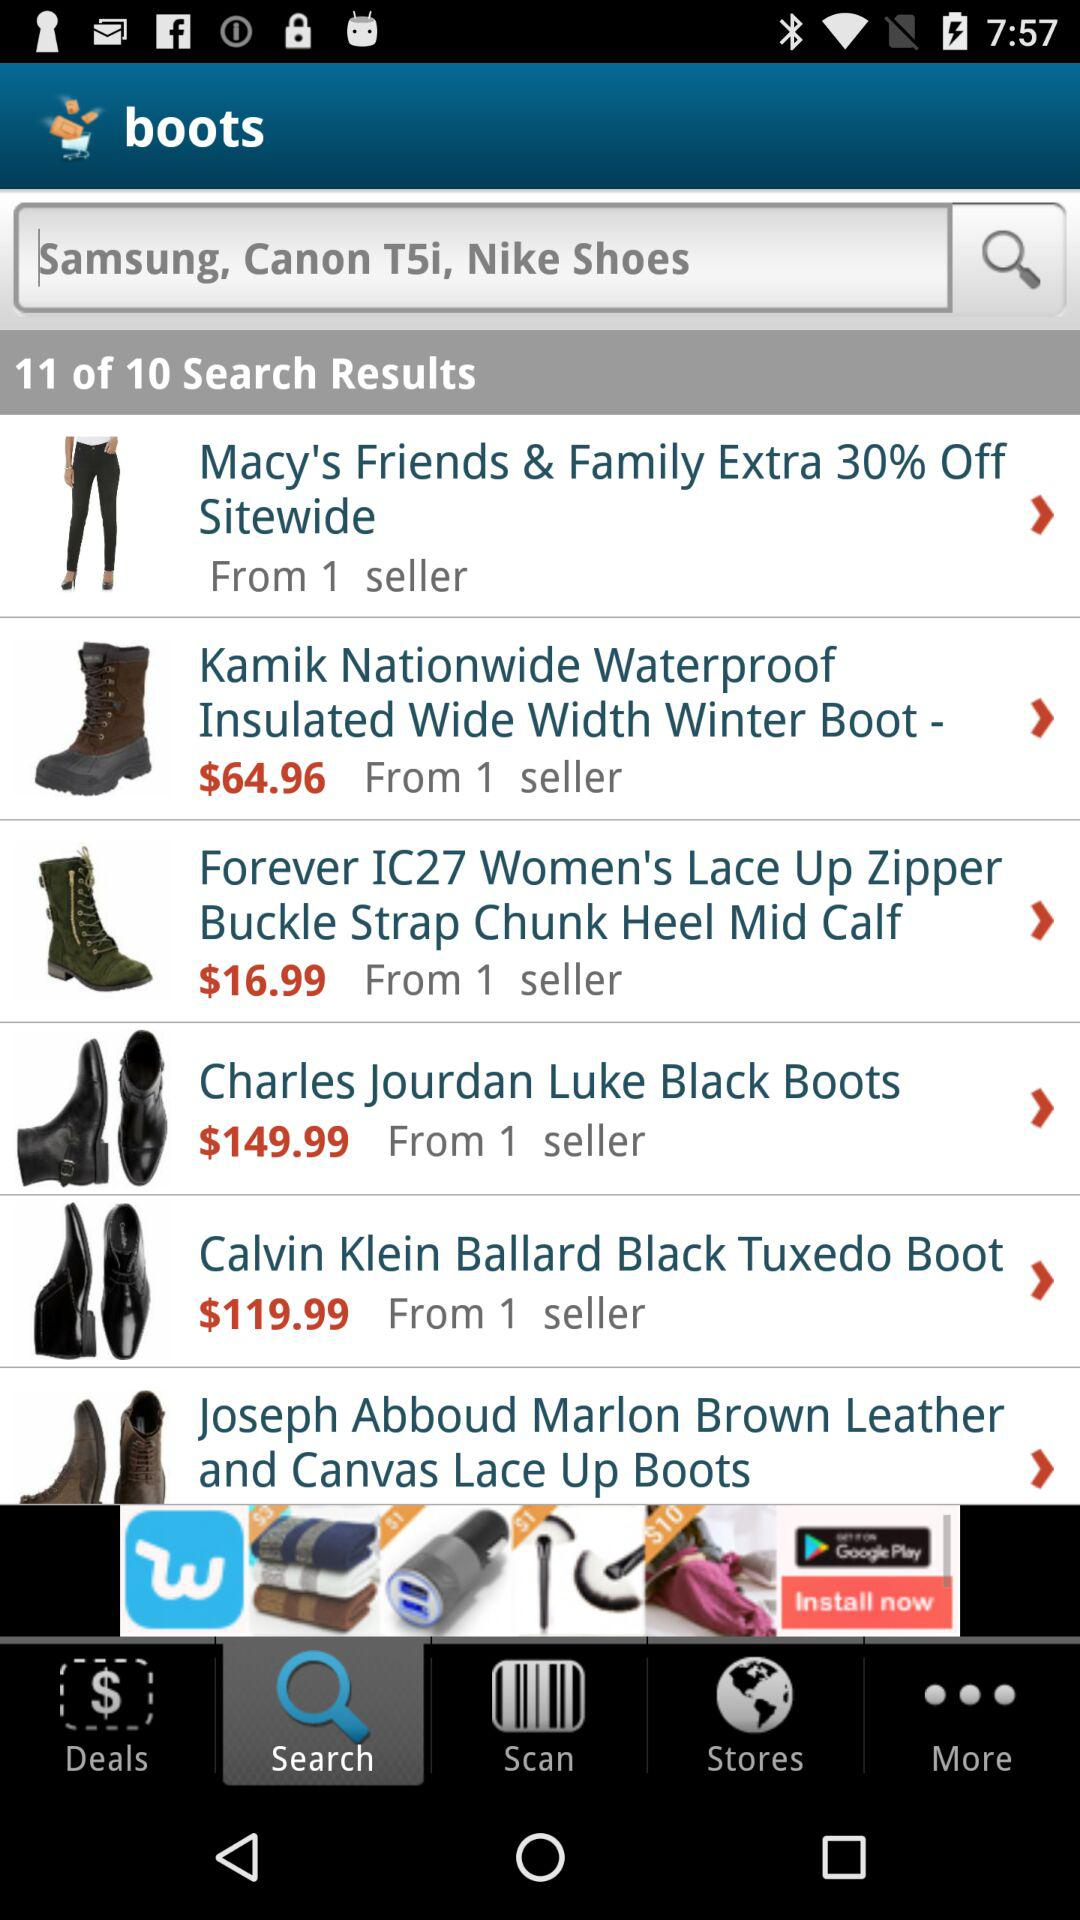How many items are on the first page of search results?
Answer the question using a single word or phrase. 6 